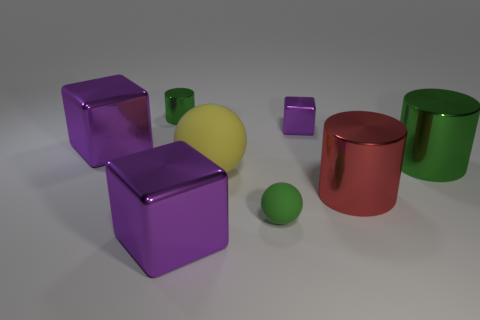Are there any other things of the same color as the small cylinder?
Offer a very short reply. Yes. There is a small metal object on the left side of the tiny green ball; what color is it?
Offer a very short reply. Green. Is there a big red shiny thing that is left of the purple metal thing that is in front of the big purple cube left of the tiny green cylinder?
Your answer should be very brief. No. Is the number of red shiny cylinders that are in front of the tiny purple object greater than the number of large red shiny cylinders?
Provide a short and direct response. No. There is a big purple metallic thing behind the big yellow sphere; does it have the same shape as the small rubber thing?
Offer a terse response. No. Is there anything else that is made of the same material as the large red thing?
Your response must be concise. Yes. What number of objects are tiny green things or metallic objects that are right of the red metal object?
Your answer should be very brief. 3. There is a shiny thing that is in front of the yellow matte object and to the right of the tiny purple block; what size is it?
Your response must be concise. Large. Is the number of small green spheres that are behind the tiny green matte thing greater than the number of shiny things on the left side of the yellow thing?
Your answer should be very brief. No. Does the large matte object have the same shape as the tiny green object to the left of the large rubber sphere?
Provide a short and direct response. No. 